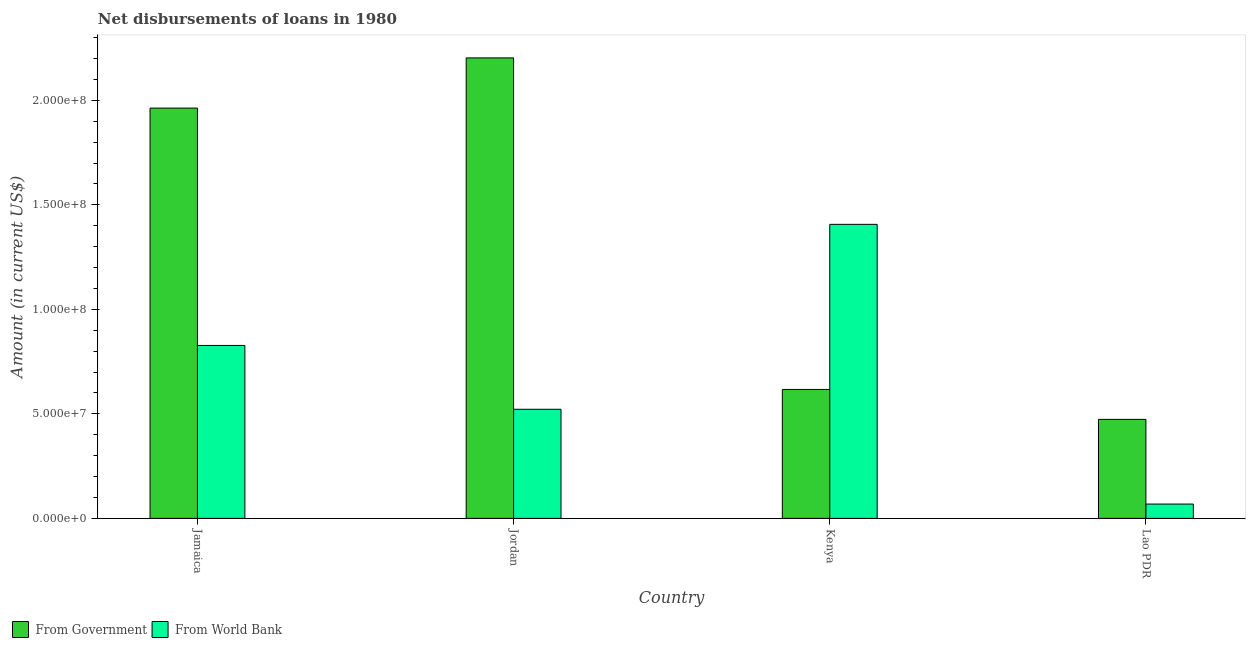How many different coloured bars are there?
Offer a terse response. 2. How many groups of bars are there?
Ensure brevity in your answer.  4. Are the number of bars per tick equal to the number of legend labels?
Make the answer very short. Yes. Are the number of bars on each tick of the X-axis equal?
Your answer should be very brief. Yes. How many bars are there on the 4th tick from the left?
Provide a succinct answer. 2. How many bars are there on the 3rd tick from the right?
Provide a short and direct response. 2. What is the label of the 3rd group of bars from the left?
Give a very brief answer. Kenya. What is the net disbursements of loan from government in Jordan?
Give a very brief answer. 2.20e+08. Across all countries, what is the maximum net disbursements of loan from government?
Provide a succinct answer. 2.20e+08. Across all countries, what is the minimum net disbursements of loan from world bank?
Make the answer very short. 6.86e+06. In which country was the net disbursements of loan from world bank maximum?
Your answer should be very brief. Kenya. In which country was the net disbursements of loan from world bank minimum?
Provide a succinct answer. Lao PDR. What is the total net disbursements of loan from government in the graph?
Your answer should be very brief. 5.26e+08. What is the difference between the net disbursements of loan from world bank in Jordan and that in Lao PDR?
Offer a very short reply. 4.53e+07. What is the difference between the net disbursements of loan from world bank in Jordan and the net disbursements of loan from government in Jamaica?
Your answer should be compact. -1.44e+08. What is the average net disbursements of loan from government per country?
Your response must be concise. 1.31e+08. What is the difference between the net disbursements of loan from government and net disbursements of loan from world bank in Kenya?
Provide a short and direct response. -7.90e+07. In how many countries, is the net disbursements of loan from world bank greater than 210000000 US$?
Your answer should be compact. 0. What is the ratio of the net disbursements of loan from government in Jordan to that in Lao PDR?
Ensure brevity in your answer.  4.65. Is the difference between the net disbursements of loan from government in Jordan and Lao PDR greater than the difference between the net disbursements of loan from world bank in Jordan and Lao PDR?
Give a very brief answer. Yes. What is the difference between the highest and the second highest net disbursements of loan from government?
Offer a terse response. 2.40e+07. What is the difference between the highest and the lowest net disbursements of loan from world bank?
Make the answer very short. 1.34e+08. What does the 1st bar from the left in Lao PDR represents?
Provide a short and direct response. From Government. What does the 1st bar from the right in Lao PDR represents?
Make the answer very short. From World Bank. How many bars are there?
Give a very brief answer. 8. What is the difference between two consecutive major ticks on the Y-axis?
Ensure brevity in your answer.  5.00e+07. Are the values on the major ticks of Y-axis written in scientific E-notation?
Offer a terse response. Yes. How are the legend labels stacked?
Offer a terse response. Horizontal. What is the title of the graph?
Provide a short and direct response. Net disbursements of loans in 1980. What is the label or title of the Y-axis?
Offer a very short reply. Amount (in current US$). What is the Amount (in current US$) of From Government in Jamaica?
Provide a succinct answer. 1.96e+08. What is the Amount (in current US$) of From World Bank in Jamaica?
Your answer should be compact. 8.27e+07. What is the Amount (in current US$) of From Government in Jordan?
Provide a succinct answer. 2.20e+08. What is the Amount (in current US$) of From World Bank in Jordan?
Offer a very short reply. 5.22e+07. What is the Amount (in current US$) in From Government in Kenya?
Ensure brevity in your answer.  6.17e+07. What is the Amount (in current US$) in From World Bank in Kenya?
Offer a very short reply. 1.41e+08. What is the Amount (in current US$) of From Government in Lao PDR?
Make the answer very short. 4.74e+07. What is the Amount (in current US$) of From World Bank in Lao PDR?
Your response must be concise. 6.86e+06. Across all countries, what is the maximum Amount (in current US$) in From Government?
Your answer should be very brief. 2.20e+08. Across all countries, what is the maximum Amount (in current US$) of From World Bank?
Your answer should be compact. 1.41e+08. Across all countries, what is the minimum Amount (in current US$) in From Government?
Ensure brevity in your answer.  4.74e+07. Across all countries, what is the minimum Amount (in current US$) in From World Bank?
Your response must be concise. 6.86e+06. What is the total Amount (in current US$) in From Government in the graph?
Offer a terse response. 5.26e+08. What is the total Amount (in current US$) in From World Bank in the graph?
Your answer should be very brief. 2.82e+08. What is the difference between the Amount (in current US$) in From Government in Jamaica and that in Jordan?
Make the answer very short. -2.40e+07. What is the difference between the Amount (in current US$) in From World Bank in Jamaica and that in Jordan?
Make the answer very short. 3.05e+07. What is the difference between the Amount (in current US$) in From Government in Jamaica and that in Kenya?
Your answer should be very brief. 1.35e+08. What is the difference between the Amount (in current US$) of From World Bank in Jamaica and that in Kenya?
Offer a terse response. -5.79e+07. What is the difference between the Amount (in current US$) of From Government in Jamaica and that in Lao PDR?
Your answer should be very brief. 1.49e+08. What is the difference between the Amount (in current US$) of From World Bank in Jamaica and that in Lao PDR?
Keep it short and to the point. 7.59e+07. What is the difference between the Amount (in current US$) in From Government in Jordan and that in Kenya?
Give a very brief answer. 1.59e+08. What is the difference between the Amount (in current US$) in From World Bank in Jordan and that in Kenya?
Offer a terse response. -8.85e+07. What is the difference between the Amount (in current US$) of From Government in Jordan and that in Lao PDR?
Provide a succinct answer. 1.73e+08. What is the difference between the Amount (in current US$) in From World Bank in Jordan and that in Lao PDR?
Offer a terse response. 4.53e+07. What is the difference between the Amount (in current US$) of From Government in Kenya and that in Lao PDR?
Offer a terse response. 1.43e+07. What is the difference between the Amount (in current US$) in From World Bank in Kenya and that in Lao PDR?
Your answer should be very brief. 1.34e+08. What is the difference between the Amount (in current US$) of From Government in Jamaica and the Amount (in current US$) of From World Bank in Jordan?
Your response must be concise. 1.44e+08. What is the difference between the Amount (in current US$) of From Government in Jamaica and the Amount (in current US$) of From World Bank in Kenya?
Keep it short and to the point. 5.56e+07. What is the difference between the Amount (in current US$) in From Government in Jamaica and the Amount (in current US$) in From World Bank in Lao PDR?
Provide a succinct answer. 1.89e+08. What is the difference between the Amount (in current US$) in From Government in Jordan and the Amount (in current US$) in From World Bank in Kenya?
Keep it short and to the point. 7.96e+07. What is the difference between the Amount (in current US$) in From Government in Jordan and the Amount (in current US$) in From World Bank in Lao PDR?
Your answer should be compact. 2.13e+08. What is the difference between the Amount (in current US$) in From Government in Kenya and the Amount (in current US$) in From World Bank in Lao PDR?
Make the answer very short. 5.48e+07. What is the average Amount (in current US$) of From Government per country?
Offer a terse response. 1.31e+08. What is the average Amount (in current US$) in From World Bank per country?
Give a very brief answer. 7.06e+07. What is the difference between the Amount (in current US$) in From Government and Amount (in current US$) in From World Bank in Jamaica?
Offer a very short reply. 1.14e+08. What is the difference between the Amount (in current US$) in From Government and Amount (in current US$) in From World Bank in Jordan?
Provide a short and direct response. 1.68e+08. What is the difference between the Amount (in current US$) in From Government and Amount (in current US$) in From World Bank in Kenya?
Provide a short and direct response. -7.90e+07. What is the difference between the Amount (in current US$) in From Government and Amount (in current US$) in From World Bank in Lao PDR?
Offer a very short reply. 4.05e+07. What is the ratio of the Amount (in current US$) in From Government in Jamaica to that in Jordan?
Give a very brief answer. 0.89. What is the ratio of the Amount (in current US$) of From World Bank in Jamaica to that in Jordan?
Make the answer very short. 1.58. What is the ratio of the Amount (in current US$) in From Government in Jamaica to that in Kenya?
Ensure brevity in your answer.  3.18. What is the ratio of the Amount (in current US$) in From World Bank in Jamaica to that in Kenya?
Keep it short and to the point. 0.59. What is the ratio of the Amount (in current US$) of From Government in Jamaica to that in Lao PDR?
Offer a terse response. 4.14. What is the ratio of the Amount (in current US$) in From World Bank in Jamaica to that in Lao PDR?
Offer a terse response. 12.06. What is the ratio of the Amount (in current US$) in From Government in Jordan to that in Kenya?
Offer a very short reply. 3.57. What is the ratio of the Amount (in current US$) of From World Bank in Jordan to that in Kenya?
Offer a terse response. 0.37. What is the ratio of the Amount (in current US$) of From Government in Jordan to that in Lao PDR?
Ensure brevity in your answer.  4.65. What is the ratio of the Amount (in current US$) of From World Bank in Jordan to that in Lao PDR?
Make the answer very short. 7.61. What is the ratio of the Amount (in current US$) in From Government in Kenya to that in Lao PDR?
Provide a short and direct response. 1.3. What is the ratio of the Amount (in current US$) in From World Bank in Kenya to that in Lao PDR?
Your answer should be very brief. 20.5. What is the difference between the highest and the second highest Amount (in current US$) of From Government?
Offer a terse response. 2.40e+07. What is the difference between the highest and the second highest Amount (in current US$) of From World Bank?
Your answer should be very brief. 5.79e+07. What is the difference between the highest and the lowest Amount (in current US$) in From Government?
Provide a succinct answer. 1.73e+08. What is the difference between the highest and the lowest Amount (in current US$) of From World Bank?
Offer a very short reply. 1.34e+08. 